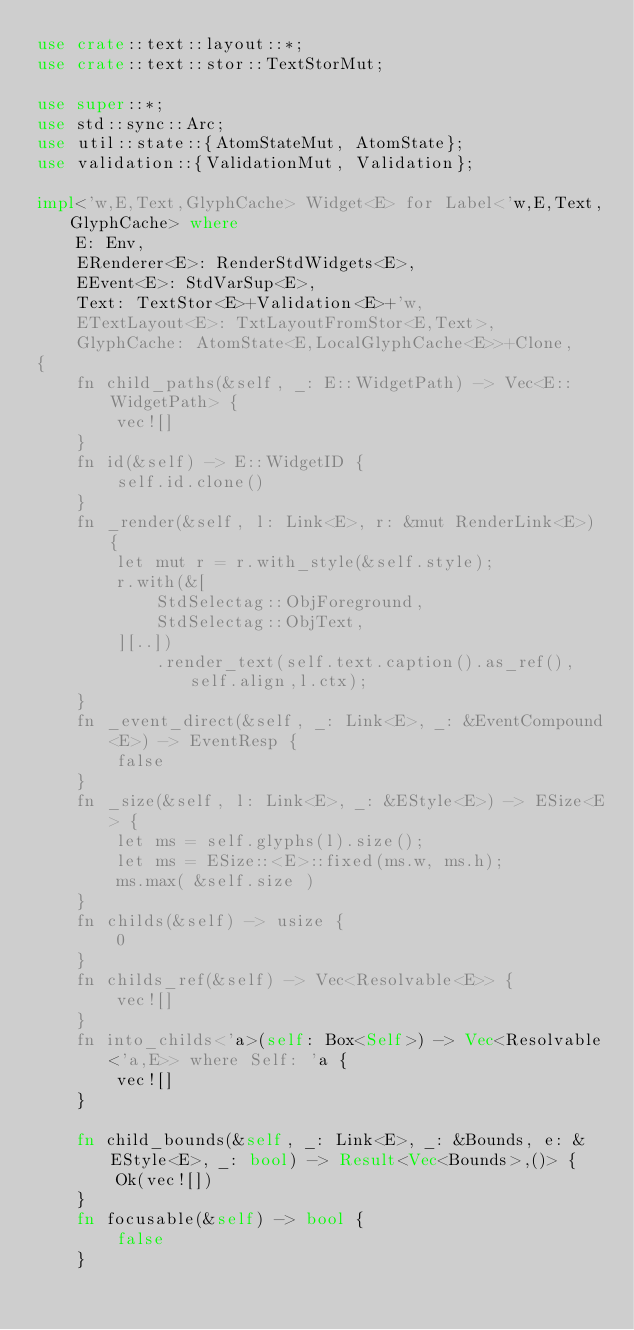<code> <loc_0><loc_0><loc_500><loc_500><_Rust_>use crate::text::layout::*;
use crate::text::stor::TextStorMut;

use super::*;
use std::sync::Arc;
use util::state::{AtomStateMut, AtomState};
use validation::{ValidationMut, Validation};

impl<'w,E,Text,GlyphCache> Widget<E> for Label<'w,E,Text,GlyphCache> where
    E: Env,
    ERenderer<E>: RenderStdWidgets<E>,
    EEvent<E>: StdVarSup<E>,
    Text: TextStor<E>+Validation<E>+'w,
    ETextLayout<E>: TxtLayoutFromStor<E,Text>,
    GlyphCache: AtomState<E,LocalGlyphCache<E>>+Clone,
{
    fn child_paths(&self, _: E::WidgetPath) -> Vec<E::WidgetPath> {
        vec![]
    }
    fn id(&self) -> E::WidgetID {
        self.id.clone()
    }
    fn _render(&self, l: Link<E>, r: &mut RenderLink<E>) {
        let mut r = r.with_style(&self.style);
        r.with(&[
            StdSelectag::ObjForeground,
            StdSelectag::ObjText,
        ][..])
            .render_text(self.text.caption().as_ref(),self.align,l.ctx);
    }
    fn _event_direct(&self, _: Link<E>, _: &EventCompound<E>) -> EventResp {
        false
    }
    fn _size(&self, l: Link<E>, _: &EStyle<E>) -> ESize<E> {
        let ms = self.glyphs(l).size();
        let ms = ESize::<E>::fixed(ms.w, ms.h);
        ms.max( &self.size )
    }
    fn childs(&self) -> usize {
        0
    }
    fn childs_ref(&self) -> Vec<Resolvable<E>> {
        vec![]
    }
    fn into_childs<'a>(self: Box<Self>) -> Vec<Resolvable<'a,E>> where Self: 'a {
        vec![]
    }
    
    fn child_bounds(&self, _: Link<E>, _: &Bounds, e: &EStyle<E>, _: bool) -> Result<Vec<Bounds>,()> {
        Ok(vec![])
    }
    fn focusable(&self) -> bool {
        false
    }</code> 